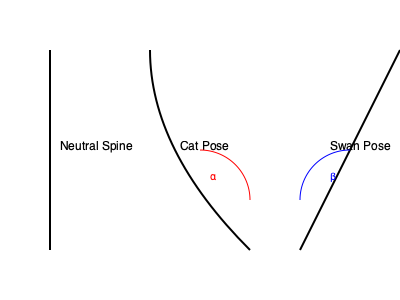In Pilates, the spine's position is crucial for proper form and effectiveness. Consider the Cat pose and Swan pose as shown in the diagram. If the angle formed by the spine in the Cat pose is $\alpha = 30°$ (convex curve), what is the approximate angle $\beta$ formed by the spine in the Swan pose (concave curve) to achieve a balanced stretch? Assume that an ideal balanced stretch requires the sum of these angles to be approximately $75°$. To solve this problem, let's follow these steps:

1. Understand the given information:
   - Cat pose spine angle: $\alpha = 30°$
   - Swan pose spine angle: $\beta$ (unknown)
   - Ideal sum of angles for balanced stretch: $75°$

2. Set up an equation based on the ideal sum:
   $\alpha + \beta \approx 75°$

3. Substitute the known value of $\alpha$:
   $30° + \beta \approx 75°$

4. Solve for $\beta$:
   $\beta \approx 75° - 30°$
   $\beta \approx 45°$

5. Interpret the result:
   The spine in the Swan pose should form an angle of approximately 45° (concave curve) to achieve a balanced stretch when paired with the Cat pose's 30° angle.

This calculation ensures that the total curvature of the spine across both poses sums to about 75°, providing a balanced and effective stretch for the spinal muscles and surrounding tissues.
Answer: $\beta \approx 45°$ 